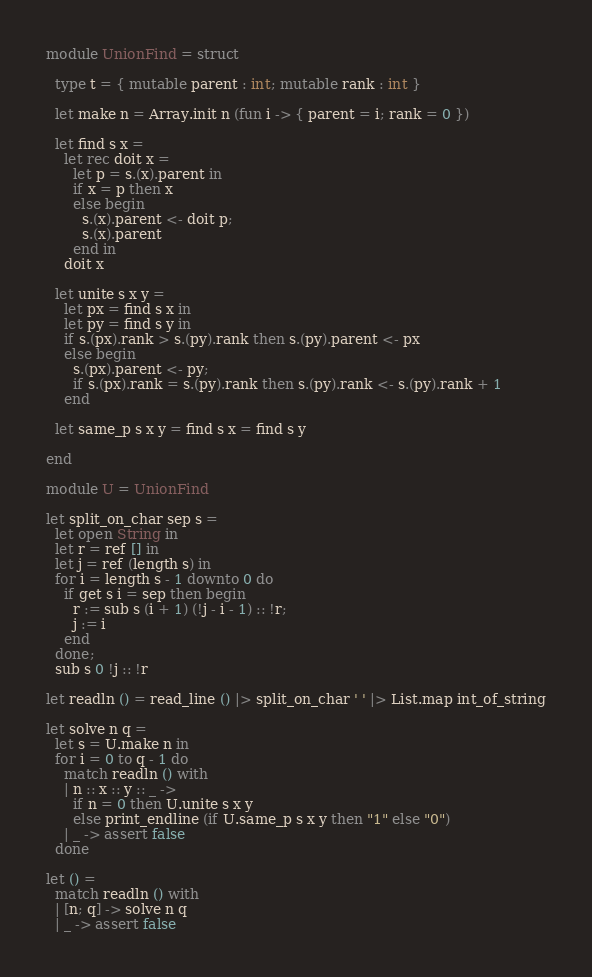Convert code to text. <code><loc_0><loc_0><loc_500><loc_500><_OCaml_>module UnionFind = struct

  type t = { mutable parent : int; mutable rank : int }

  let make n = Array.init n (fun i -> { parent = i; rank = 0 })

  let find s x =
    let rec doit x =
      let p = s.(x).parent in
      if x = p then x
      else begin
        s.(x).parent <- doit p;
        s.(x).parent
      end in
    doit x

  let unite s x y =
    let px = find s x in
    let py = find s y in
    if s.(px).rank > s.(py).rank then s.(py).parent <- px
    else begin
      s.(px).parent <- py;
      if s.(px).rank = s.(py).rank then s.(py).rank <- s.(py).rank + 1
    end

  let same_p s x y = find s x = find s y

end

module U = UnionFind

let split_on_char sep s =
  let open String in
  let r = ref [] in
  let j = ref (length s) in
  for i = length s - 1 downto 0 do
    if get s i = sep then begin
      r := sub s (i + 1) (!j - i - 1) :: !r;
      j := i
    end
  done;
  sub s 0 !j :: !r

let readln () = read_line () |> split_on_char ' ' |> List.map int_of_string

let solve n q =
  let s = U.make n in
  for i = 0 to q - 1 do
    match readln () with
    | n :: x :: y :: _ ->
      if n = 0 then U.unite s x y
      else print_endline (if U.same_p s x y then "1" else "0")
    | _ -> assert false
  done

let () =
  match readln () with
  | [n; q] -> solve n q
  | _ -> assert false</code> 